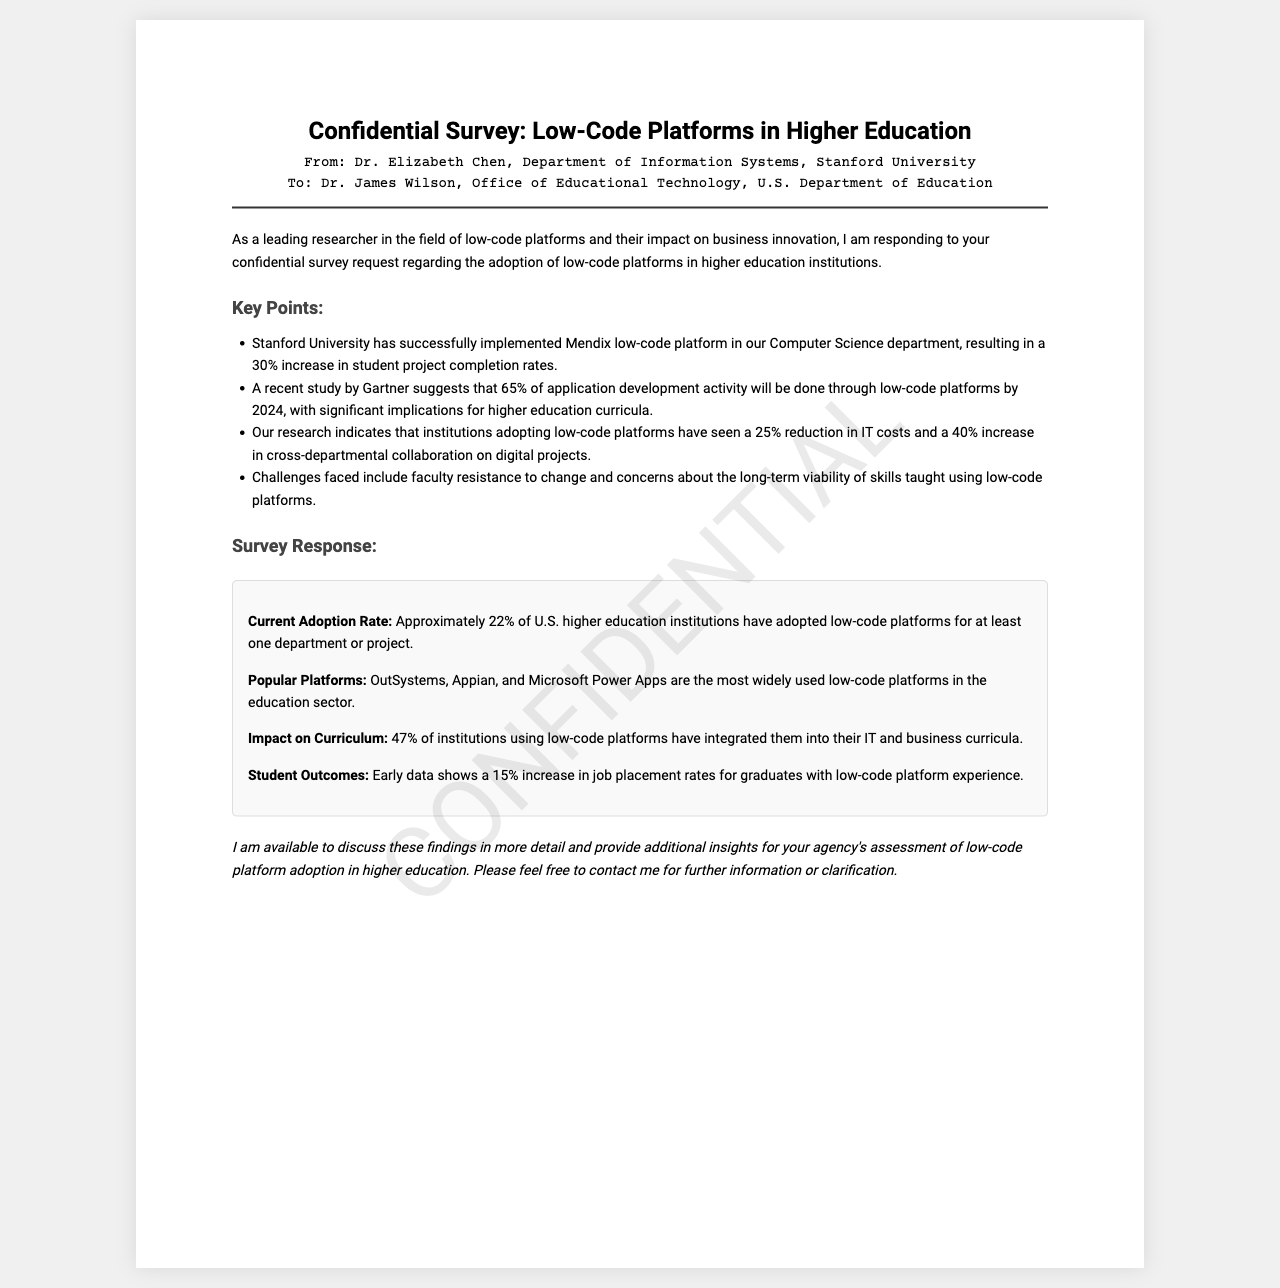What is the adoption rate of low-code platforms in U.S. higher education institutions? The document states that approximately 22% of U.S. higher education institutions have adopted low-code platforms.
Answer: 22% Which low-code platforms are mentioned as the most popular in the education sector? The document lists OutSystems, Appian, and Microsoft Power Apps as the most widely used low-code platforms.
Answer: OutSystems, Appian, Microsoft Power Apps What increase in project completion rates has Stanford University experienced after implementing a low-code platform? The document indicates a 30% increase in student project completion rates at Stanford University.
Answer: 30% What percentage of institutions using low-code platforms have integrated them into their curricula? According to the document, 47% of institutions using low-code platforms have integrated them into their IT and business curricula.
Answer: 47% What challenges are mentioned regarding the adoption of low-code platforms? The document highlights faculty resistance to change and concerns about the long-term viability of skills taught using low-code platforms as challenges.
Answer: Faculty resistance and concerns about long-term viability Who is the sender of the confidential survey request? The document specifies that Dr. Elizabeth Chen from Stanford University is the sender.
Answer: Dr. Elizabeth Chen How much reduction in IT costs have institutions adopting low-code platforms seen? The document states a 25% reduction in IT costs for institutions that have adopted low-code platforms.
Answer: 25% What does the early data suggest about job placement rates for graduates with low-code platform experience? The document mentions that early data shows a 15% increase in job placement rates for such graduates.
Answer: 15% 